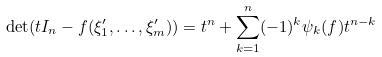<formula> <loc_0><loc_0><loc_500><loc_500>\det ( t I _ { n } - f ( \xi _ { 1 } ^ { \prime } , \dots , \xi _ { m } ^ { \prime } ) ) = t ^ { n } + \sum _ { k = 1 } ^ { n } ( - 1 ) ^ { k } \psi _ { k } ( f ) t ^ { n - k }</formula> 